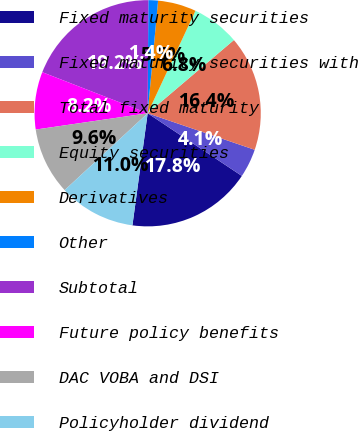<chart> <loc_0><loc_0><loc_500><loc_500><pie_chart><fcel>Fixed maturity securities<fcel>Fixed maturity securities with<fcel>Total fixed maturity<fcel>Equity securities<fcel>Derivatives<fcel>Other<fcel>Subtotal<fcel>Future policy benefits<fcel>DAC VOBA and DSI<fcel>Policyholder dividend<nl><fcel>17.81%<fcel>4.11%<fcel>16.44%<fcel>6.85%<fcel>5.48%<fcel>1.37%<fcel>19.18%<fcel>8.22%<fcel>9.59%<fcel>10.96%<nl></chart> 